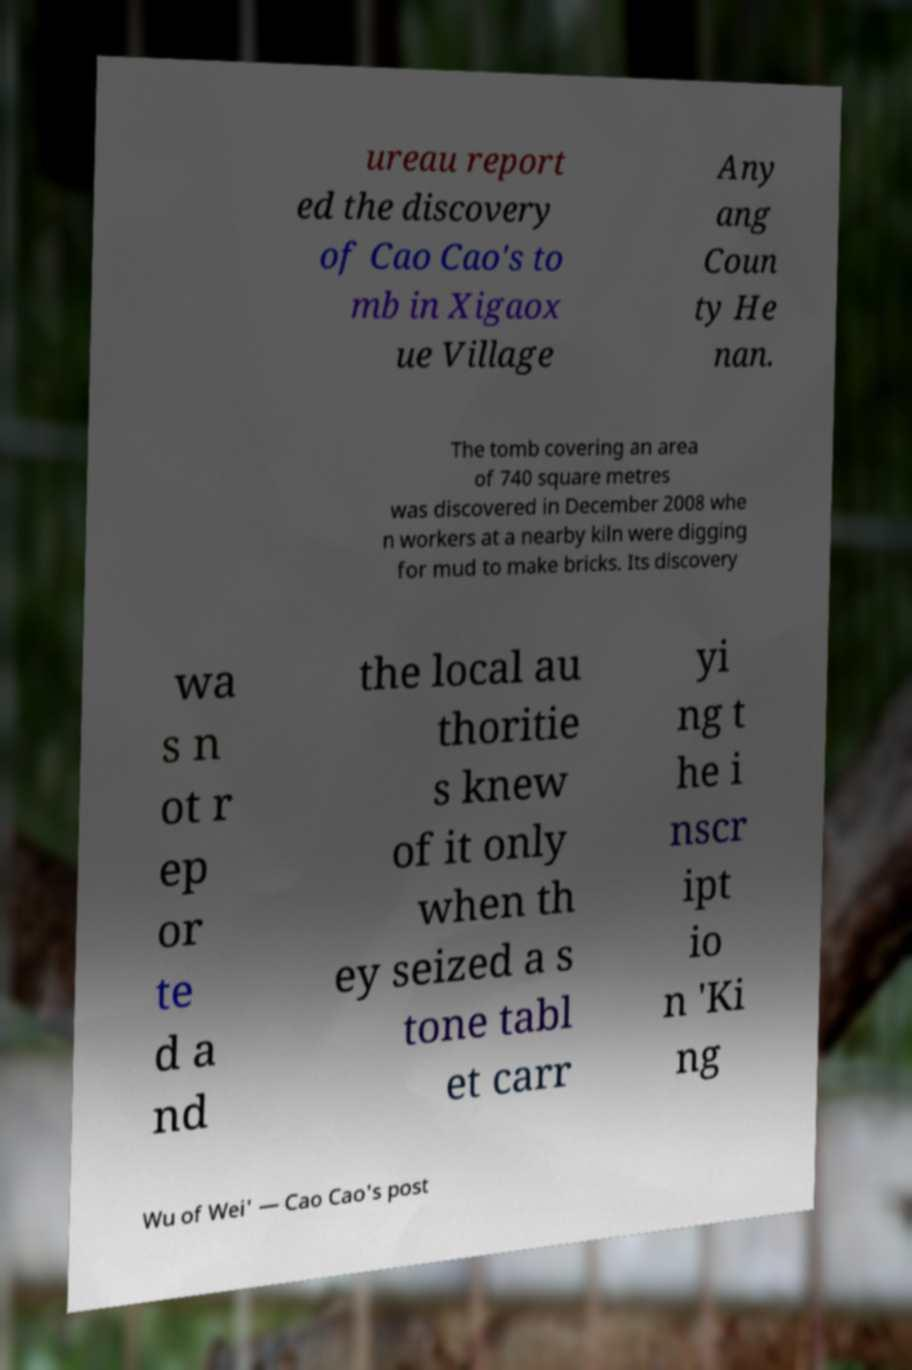Please identify and transcribe the text found in this image. ureau report ed the discovery of Cao Cao's to mb in Xigaox ue Village Any ang Coun ty He nan. The tomb covering an area of 740 square metres was discovered in December 2008 whe n workers at a nearby kiln were digging for mud to make bricks. Its discovery wa s n ot r ep or te d a nd the local au thoritie s knew of it only when th ey seized a s tone tabl et carr yi ng t he i nscr ipt io n 'Ki ng Wu of Wei' — Cao Cao's post 